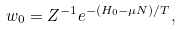<formula> <loc_0><loc_0><loc_500><loc_500>w _ { 0 } = Z ^ { - 1 } e ^ { - ( H _ { 0 } - \mu N ) / T } ,</formula> 